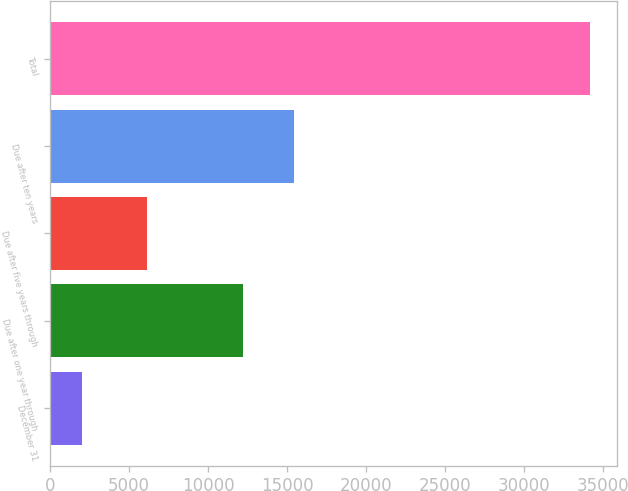<chart> <loc_0><loc_0><loc_500><loc_500><bar_chart><fcel>December 31<fcel>Due after one year through<fcel>Due after five years through<fcel>Due after ten years<fcel>Total<nl><fcel>2007<fcel>12219<fcel>6150<fcel>15439.5<fcel>34212<nl></chart> 